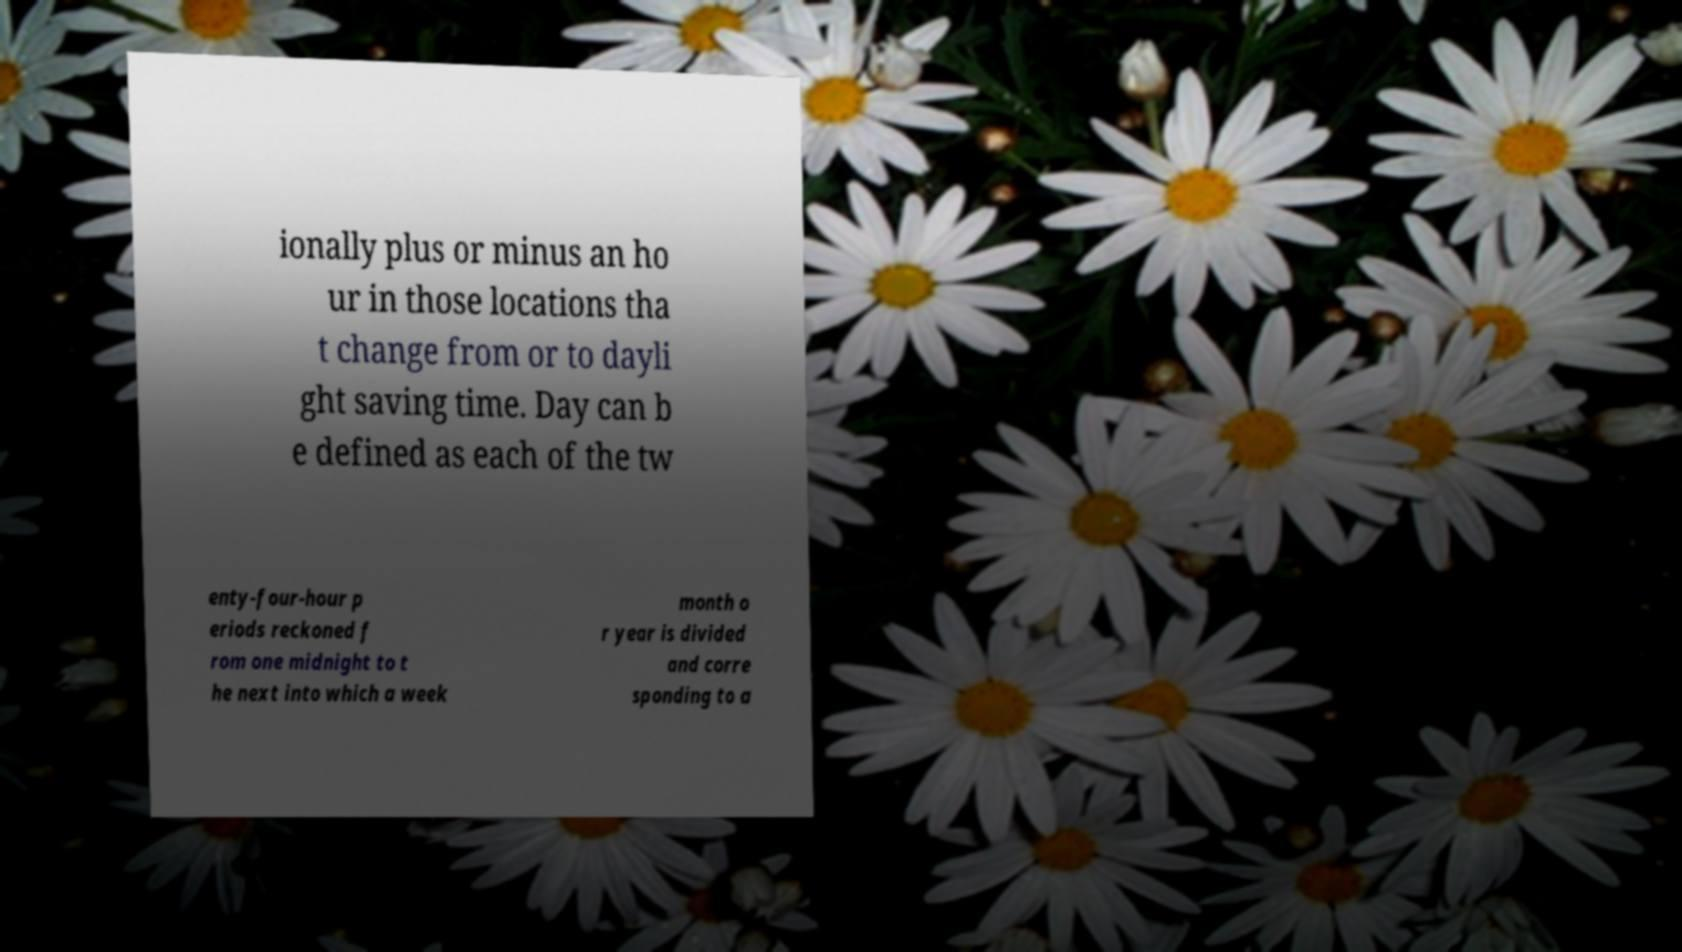What messages or text are displayed in this image? I need them in a readable, typed format. ionally plus or minus an ho ur in those locations tha t change from or to dayli ght saving time. Day can b e defined as each of the tw enty-four-hour p eriods reckoned f rom one midnight to t he next into which a week month o r year is divided and corre sponding to a 